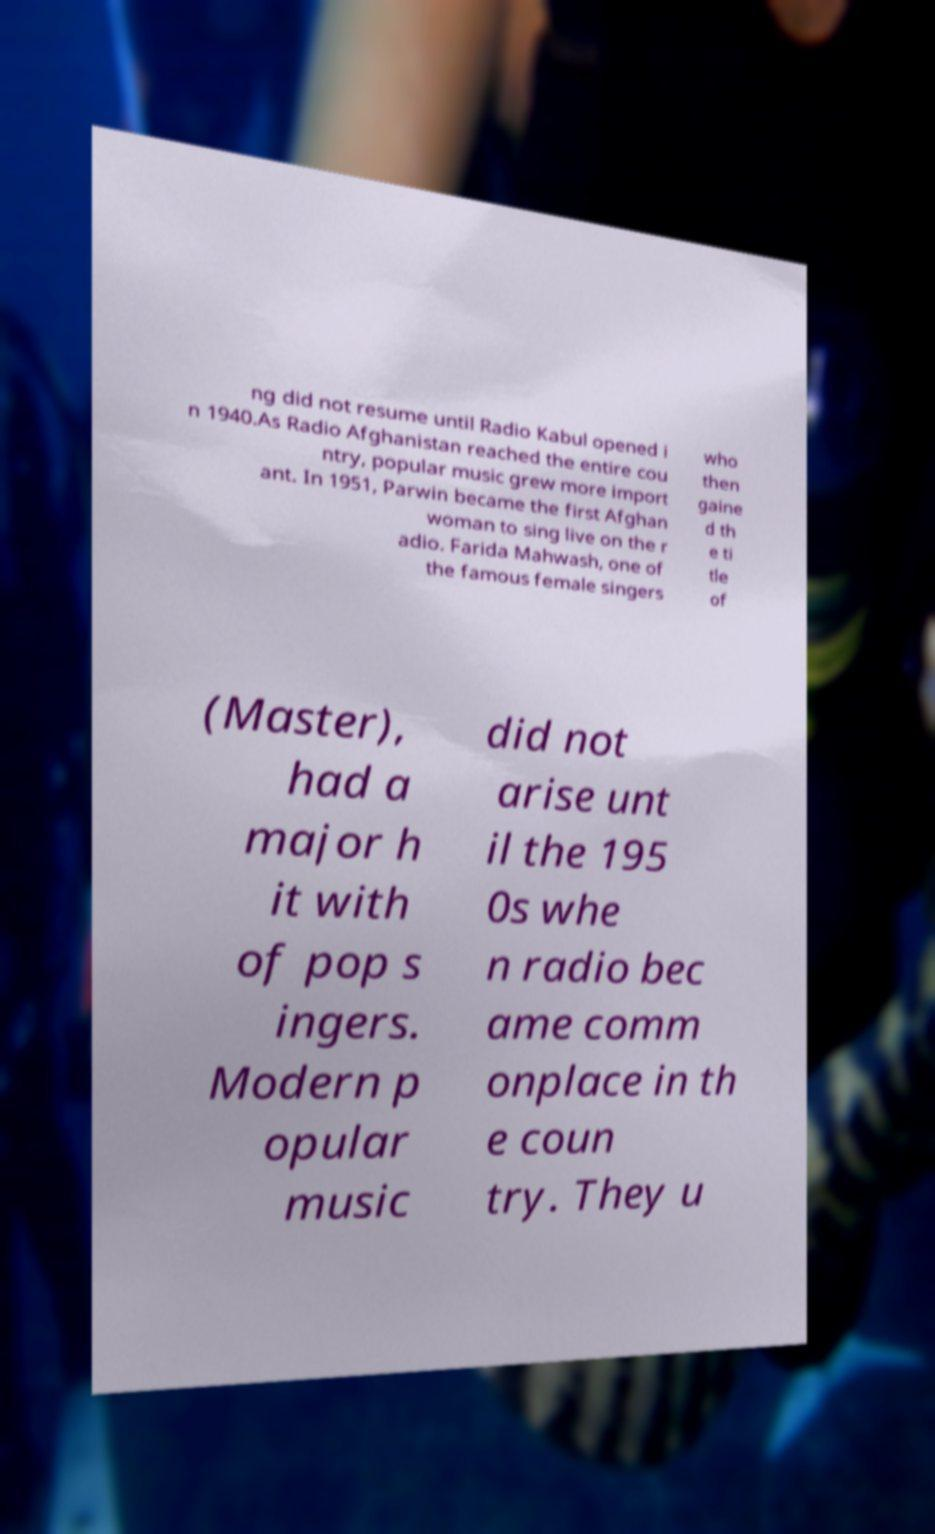For documentation purposes, I need the text within this image transcribed. Could you provide that? ng did not resume until Radio Kabul opened i n 1940.As Radio Afghanistan reached the entire cou ntry, popular music grew more import ant. In 1951, Parwin became the first Afghan woman to sing live on the r adio. Farida Mahwash, one of the famous female singers who then gaine d th e ti tle of (Master), had a major h it with of pop s ingers. Modern p opular music did not arise unt il the 195 0s whe n radio bec ame comm onplace in th e coun try. They u 